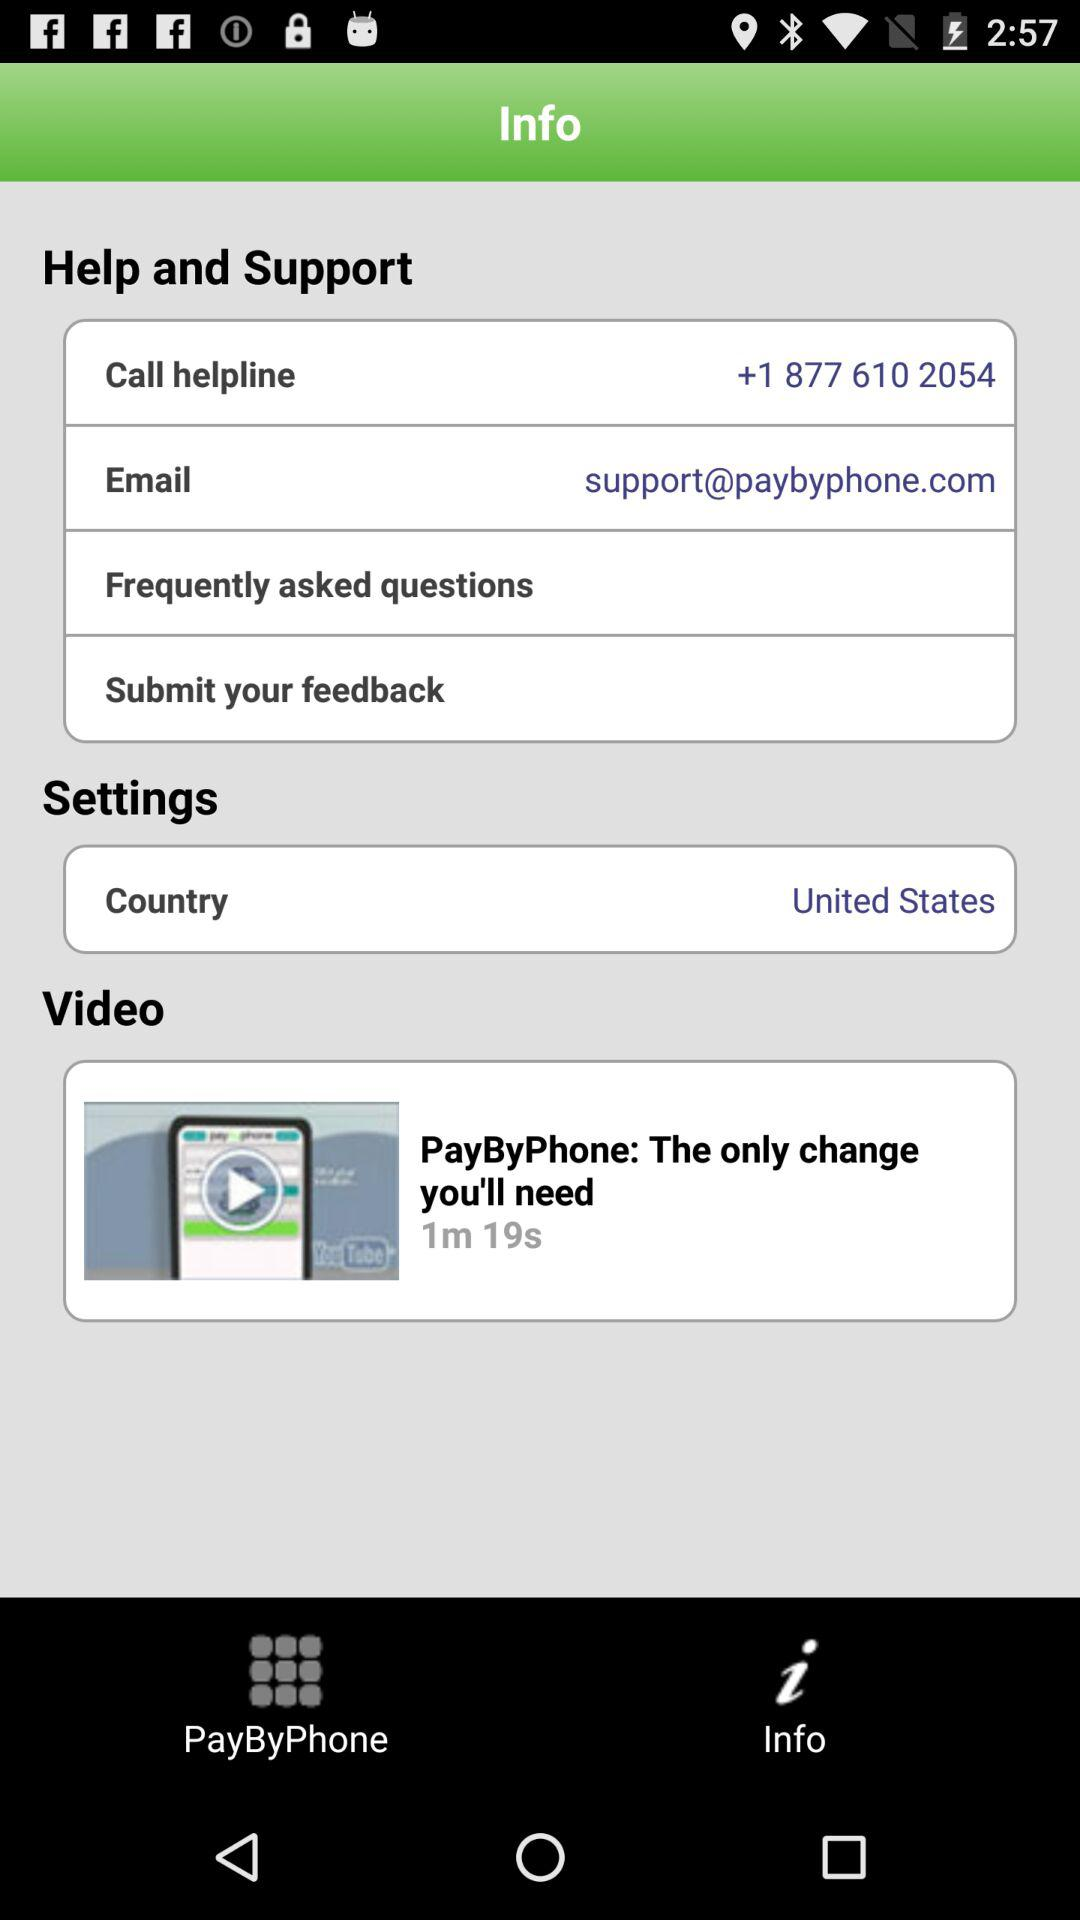What country has been selected? The selected country is the United States. 